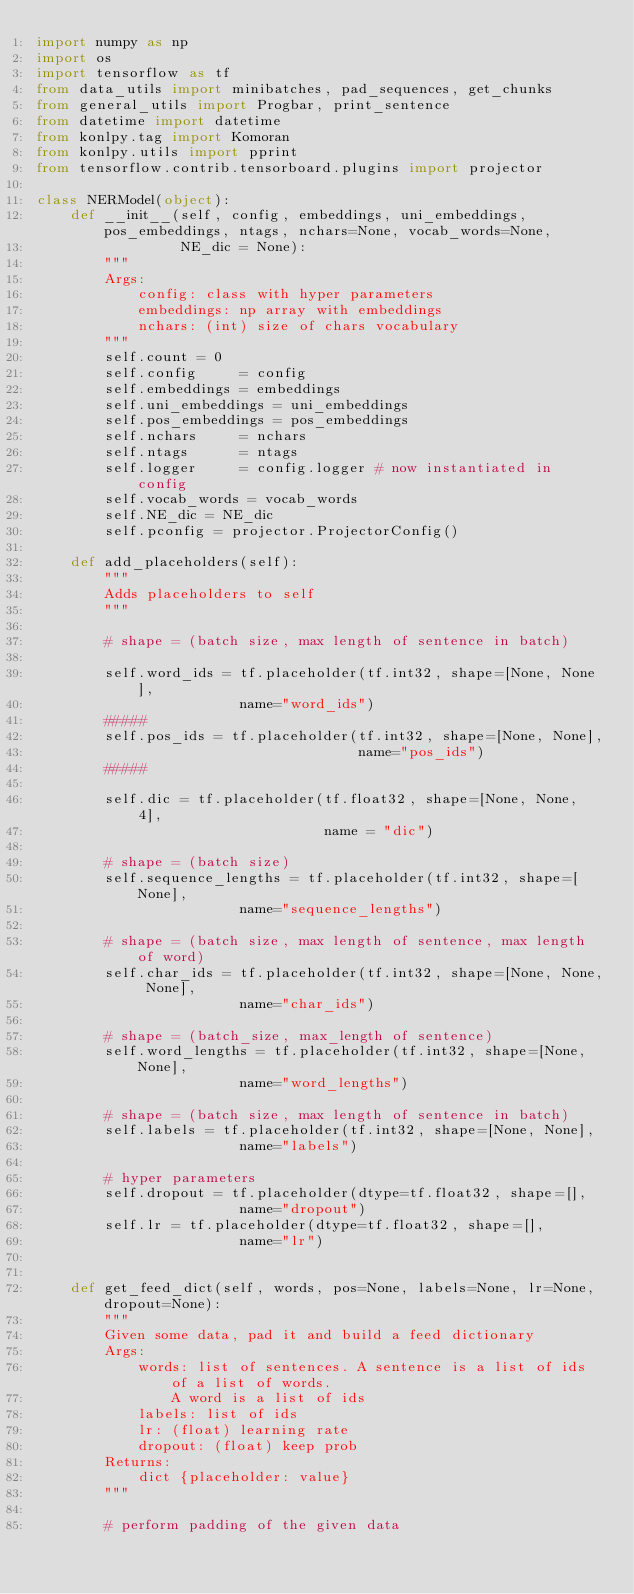<code> <loc_0><loc_0><loc_500><loc_500><_Python_>import numpy as np
import os
import tensorflow as tf
from data_utils import minibatches, pad_sequences, get_chunks
from general_utils import Progbar, print_sentence
from datetime import datetime
from konlpy.tag import Komoran
from konlpy.utils import pprint
from tensorflow.contrib.tensorboard.plugins import projector

class NERModel(object):
    def __init__(self, config, embeddings, uni_embeddings, pos_embeddings, ntags, nchars=None, vocab_words=None,
                 NE_dic = None):
        """
        Args:
            config: class with hyper parameters
            embeddings: np array with embeddings
            nchars: (int) size of chars vocabulary
        """
        self.count = 0
        self.config     = config
        self.embeddings = embeddings
        self.uni_embeddings = uni_embeddings
        self.pos_embeddings = pos_embeddings
        self.nchars     = nchars
        self.ntags      = ntags
        self.logger     = config.logger # now instantiated in config
        self.vocab_words = vocab_words
        self.NE_dic = NE_dic
        self.pconfig = projector.ProjectorConfig()

    def add_placeholders(self):
        """
        Adds placeholders to self
        """

        # shape = (batch size, max length of sentence in batch)

        self.word_ids = tf.placeholder(tf.int32, shape=[None, None],
                        name="word_ids")
        #####
        self.pos_ids = tf.placeholder(tf.int32, shape=[None, None],
                                      name="pos_ids")
        #####

        self.dic = tf.placeholder(tf.float32, shape=[None, None, 4],
                                  name = "dic")

        # shape = (batch size)
        self.sequence_lengths = tf.placeholder(tf.int32, shape=[None],
                        name="sequence_lengths")

        # shape = (batch size, max length of sentence, max length of word)
        self.char_ids = tf.placeholder(tf.int32, shape=[None, None, None],
                        name="char_ids")

        # shape = (batch_size, max_length of sentence)
        self.word_lengths = tf.placeholder(tf.int32, shape=[None, None],
                        name="word_lengths")

        # shape = (batch size, max length of sentence in batch)
        self.labels = tf.placeholder(tf.int32, shape=[None, None],
                        name="labels")

        # hyper parameters
        self.dropout = tf.placeholder(dtype=tf.float32, shape=[],
                        name="dropout")
        self.lr = tf.placeholder(dtype=tf.float32, shape=[],
                        name="lr")


    def get_feed_dict(self, words, pos=None, labels=None, lr=None, dropout=None):
        """
        Given some data, pad it and build a feed dictionary
        Args:
            words: list of sentences. A sentence is a list of ids of a list of words. 
                A word is a list of ids
            labels: list of ids
            lr: (float) learning rate
            dropout: (float) keep prob
        Returns:
            dict {placeholder: value}
        """

        # perform padding of the given data</code> 